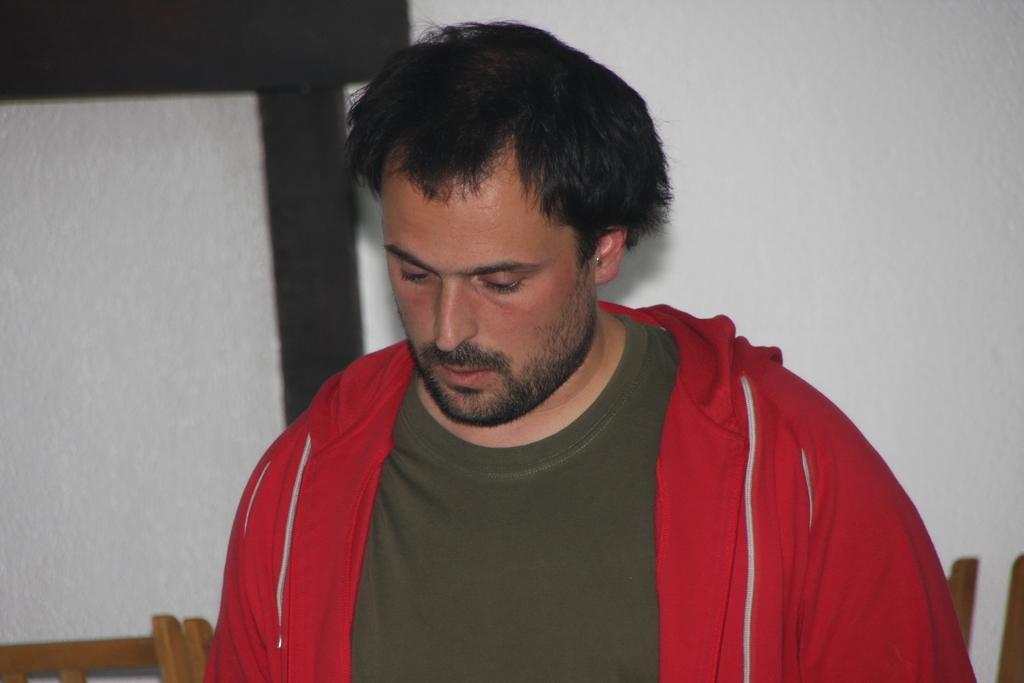Can you describe this image briefly? In this image I can see the person and the person is wearing brown and red color dress. In the background I can see few wooden objects and the wall is in white color. 